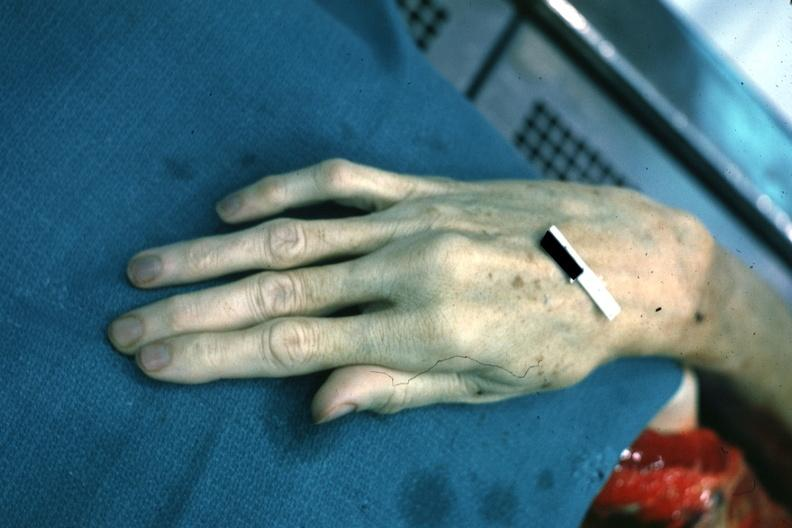what is present?
Answer the question using a single word or phrase. Marfans syndrome 